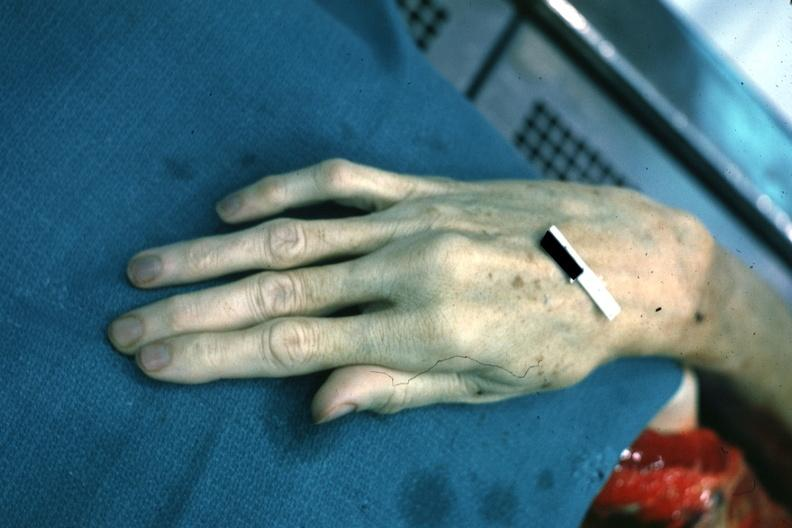what is present?
Answer the question using a single word or phrase. Marfans syndrome 